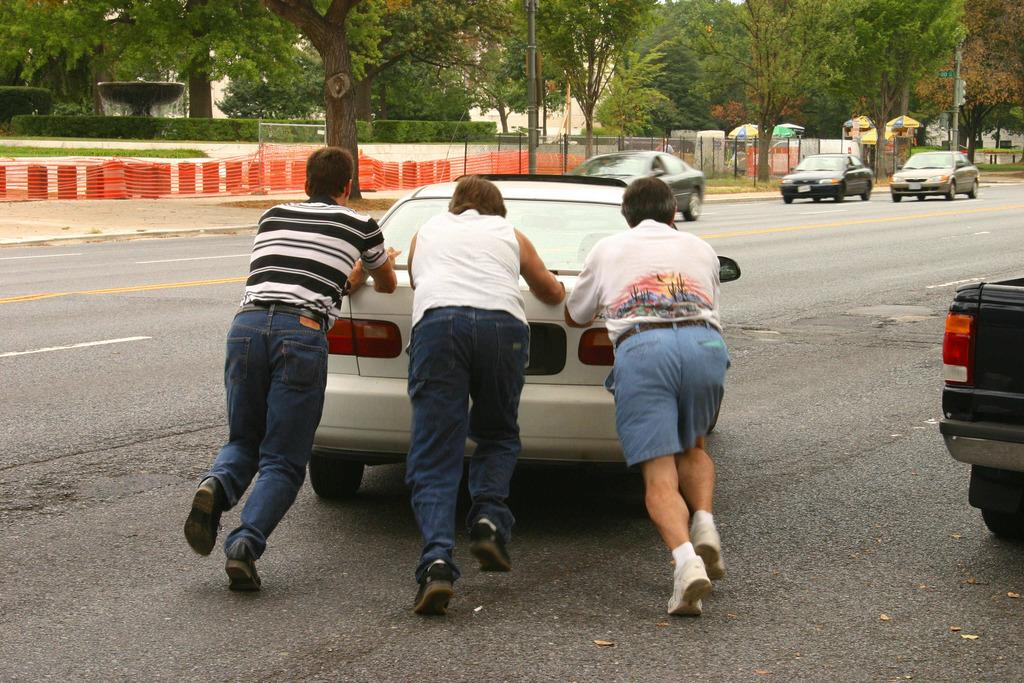What is happening on the road in the image? There are cars on the road in the image, and three men are pushing a car. What can be seen in the background of the image? There are trees visible in the background of the image. What is the purpose of the fence in the image? The purpose of the fence in the image is not specified, but it could be for enclosing a property or separating areas. What is the fountain in the image used for? The fountain in the image is likely used for decoration or as a water feature. What might people use to protect themselves from the sun or rain in the image? Umbrellas are present in the image for protection from the sun or rain. Can you tell me how many cats are sitting on the fence in the image? There are no cats present in the image; it features cars, men pushing a car, a fence, a fountain, umbrellas, and trees in the background. What type of brick is used to build the fountain in the image? There is no mention of bricks in the image; the fountain is not described as being made of bricks. 